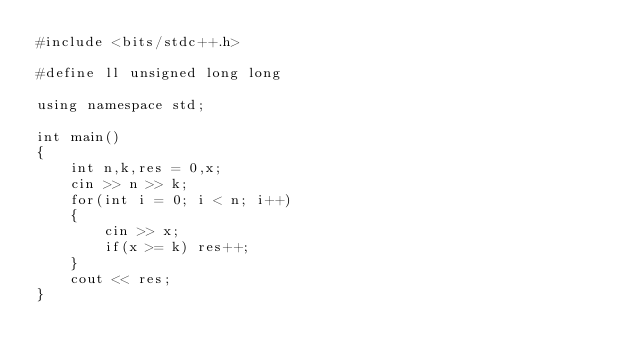<code> <loc_0><loc_0><loc_500><loc_500><_C++_>#include <bits/stdc++.h>

#define ll unsigned long long

using namespace std;

int main()
{
    int n,k,res = 0,x;
    cin >> n >> k;
    for(int i = 0; i < n; i++)
    {
        cin >> x;
        if(x >= k) res++;
    }
    cout << res;
}
</code> 